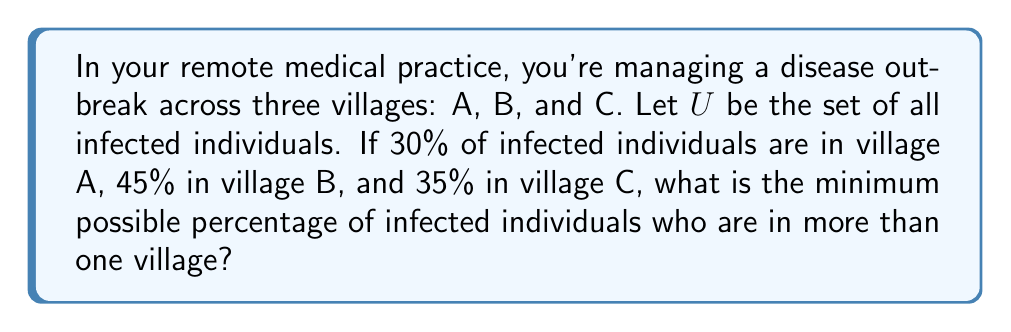Can you solve this math problem? Let's approach this step-by-step using set theory:

1) Let's define our sets:
   $A$ = infected individuals in village A
   $B$ = infected individuals in village B
   $C$ = infected individuals in village C

2) We're given the following information:
   $|A| = 30\%$ of $|U|$
   $|B| = 45\%$ of $|U|$
   $|C| = 35\%$ of $|U|$

3) If we add these percentages:
   $30\% + 45\% + 35\% = 110\%$

4) This sum exceeds 100%, which means there must be some overlap between the sets.

5) To find the minimum overlap, we use the principle of inclusion-exclusion:
   $|A \cup B \cup C| = |A| + |B| + |C| - |A \cap B| - |B \cap C| - |A \cap C| + |A \cap B \cap C|$

6) We know that $|A \cup B \cup C| = |U| = 100\%$ of infected individuals.

7) Substituting the known values:
   $100\% = 30\% + 45\% + 35\% - |A \cap B| - |B \cap C| - |A \cap C| + |A \cap B \cap C|$

8) Simplifying:
   $100\% = 110\% - (|A \cap B| + |B \cap C| + |A \cap C| - |A \cap B \cap C|)$

9) Solving for the overlap:
   $|A \cap B| + |B \cap C| + |A \cap C| - |A \cap B \cap C| = 10\%$

10) To minimize this overlap, we assume $|A \cap B \cap C| = 0$. Thus:
    $|A \cap B| + |B \cap C| + |A \cap C| = 10\%$

Therefore, the minimum percentage of infected individuals who are in more than one village is 10%.
Answer: 10% 